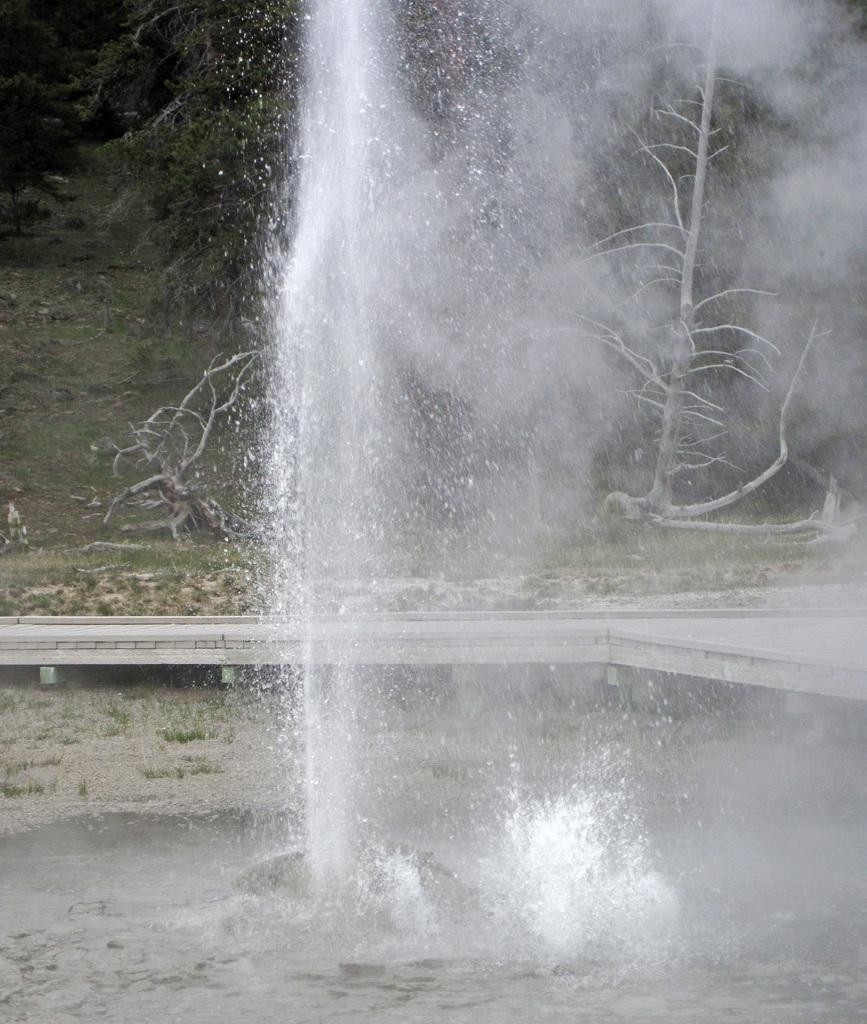In one or two sentences, can you explain what this image depicts? In this image I can see the water fountain in front and in the background I can see the ground on which there are trees. 